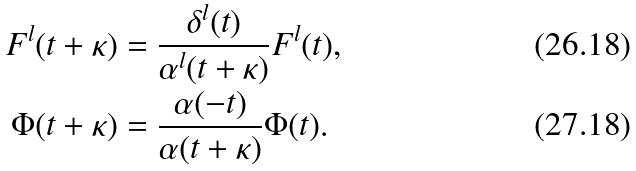<formula> <loc_0><loc_0><loc_500><loc_500>F ^ { l } ( t + \kappa ) & = \frac { \delta ^ { l } ( t ) } { \alpha ^ { l } ( t + \kappa ) } F ^ { l } ( t ) , \\ \Phi ( t + \kappa ) & = \frac { \alpha ( - t ) } { \alpha ( t + \kappa ) } \Phi ( t ) .</formula> 